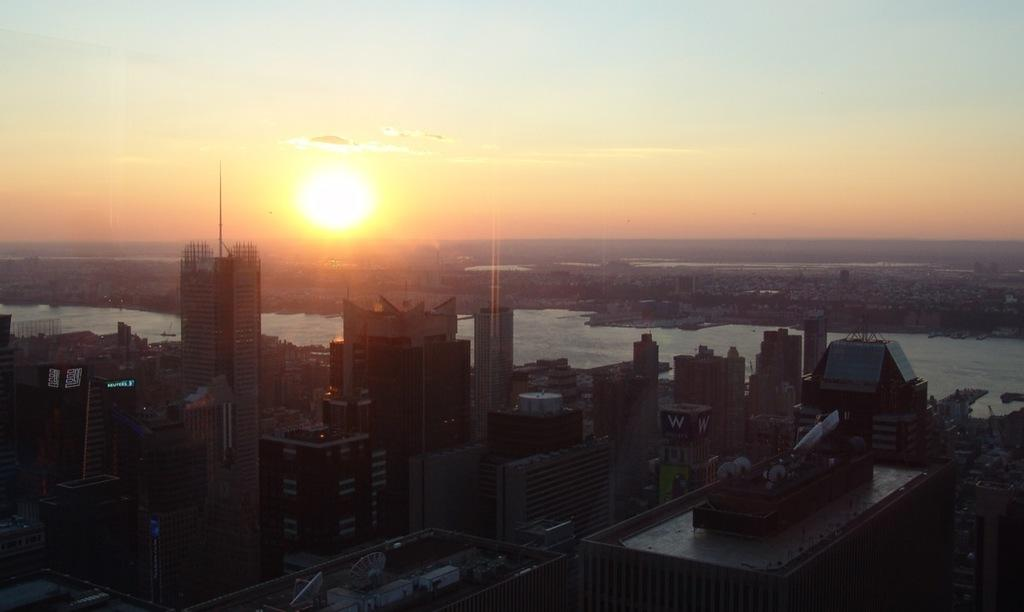What type of structures can be seen in the image? There are buildings in the image. What natural feature is present in the image? There is a lake in the image. What celestial body is visible in the image? The sun is visible in the image. What part of the natural environment is visible in the image? The sky is visible in the image. How would you describe the weather based on the sky's appearance? The sky appears cloudy in the image. What type of plantation can be seen in the image? There is no plantation present in the image. What type of work is being done in the image? The image does not depict any specific work or activity. 